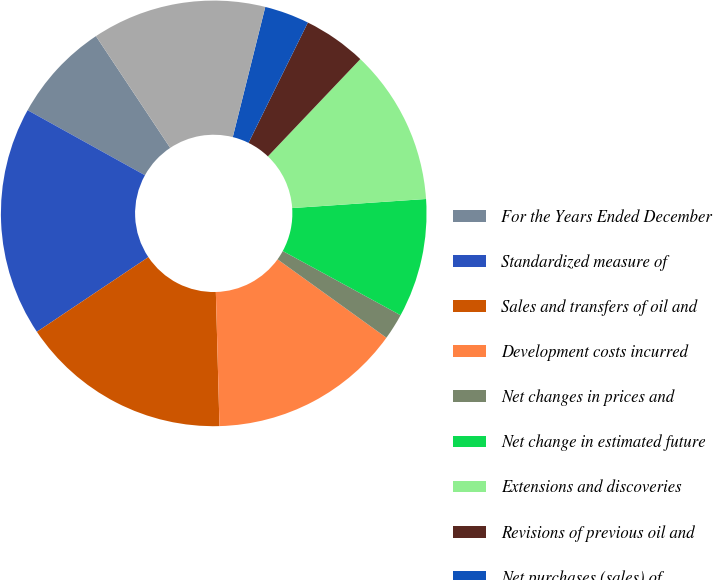<chart> <loc_0><loc_0><loc_500><loc_500><pie_chart><fcel>For the Years Ended December<fcel>Standardized measure of<fcel>Sales and transfers of oil and<fcel>Development costs incurred<fcel>Net changes in prices and<fcel>Net change in estimated future<fcel>Extensions and discoveries<fcel>Revisions of previous oil and<fcel>Net purchases (sales) of<fcel>Accretion of discount<nl><fcel>7.61%<fcel>17.45%<fcel>16.04%<fcel>14.64%<fcel>1.99%<fcel>9.02%<fcel>11.83%<fcel>4.8%<fcel>3.4%<fcel>13.23%<nl></chart> 